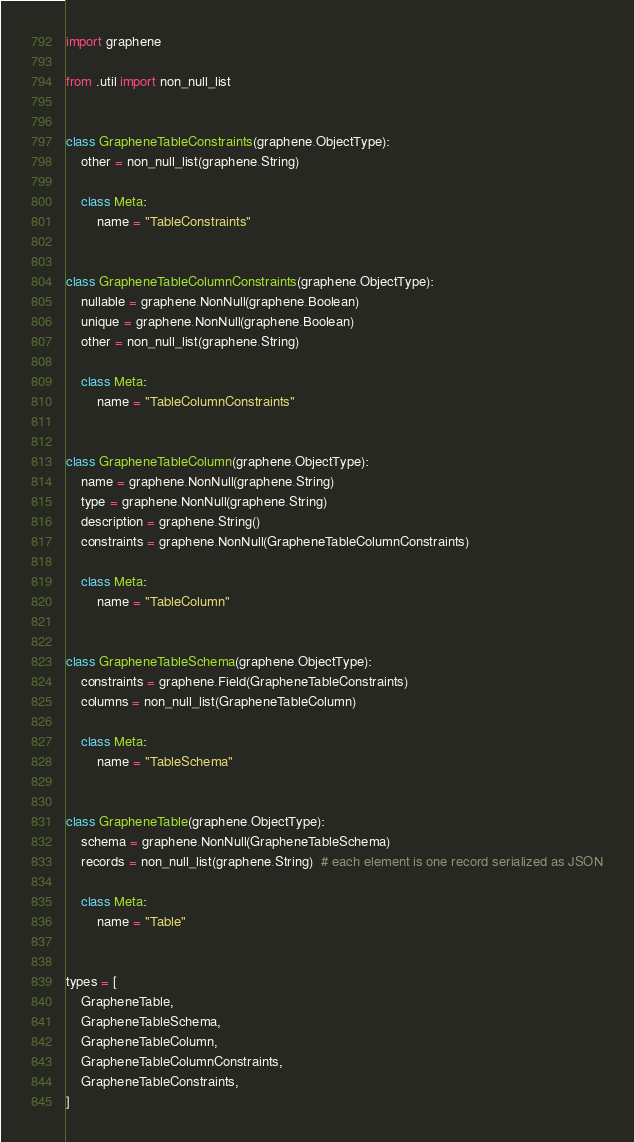<code> <loc_0><loc_0><loc_500><loc_500><_Python_>import graphene

from .util import non_null_list


class GrapheneTableConstraints(graphene.ObjectType):
    other = non_null_list(graphene.String)

    class Meta:
        name = "TableConstraints"


class GrapheneTableColumnConstraints(graphene.ObjectType):
    nullable = graphene.NonNull(graphene.Boolean)
    unique = graphene.NonNull(graphene.Boolean)
    other = non_null_list(graphene.String)

    class Meta:
        name = "TableColumnConstraints"


class GrapheneTableColumn(graphene.ObjectType):
    name = graphene.NonNull(graphene.String)
    type = graphene.NonNull(graphene.String)
    description = graphene.String()
    constraints = graphene.NonNull(GrapheneTableColumnConstraints)

    class Meta:
        name = "TableColumn"


class GrapheneTableSchema(graphene.ObjectType):
    constraints = graphene.Field(GrapheneTableConstraints)
    columns = non_null_list(GrapheneTableColumn)

    class Meta:
        name = "TableSchema"


class GrapheneTable(graphene.ObjectType):
    schema = graphene.NonNull(GrapheneTableSchema)
    records = non_null_list(graphene.String)  # each element is one record serialized as JSON

    class Meta:
        name = "Table"


types = [
    GrapheneTable,
    GrapheneTableSchema,
    GrapheneTableColumn,
    GrapheneTableColumnConstraints,
    GrapheneTableConstraints,
]
</code> 